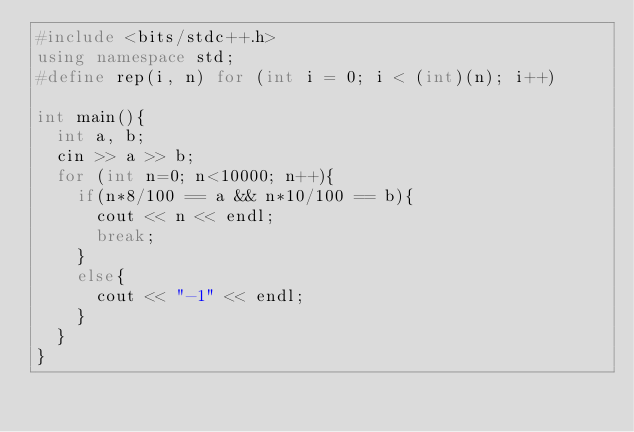<code> <loc_0><loc_0><loc_500><loc_500><_C++_>#include <bits/stdc++.h>
using namespace std;
#define rep(i, n) for (int i = 0; i < (int)(n); i++)

int main(){
  int a, b;
  cin >> a >> b;
  for (int n=0; n<10000; n++){
    if(n*8/100 == a && n*10/100 == b){
      cout << n << endl;
      break;
    }
    else{
      cout << "-1" << endl;
    }
  }
}
</code> 